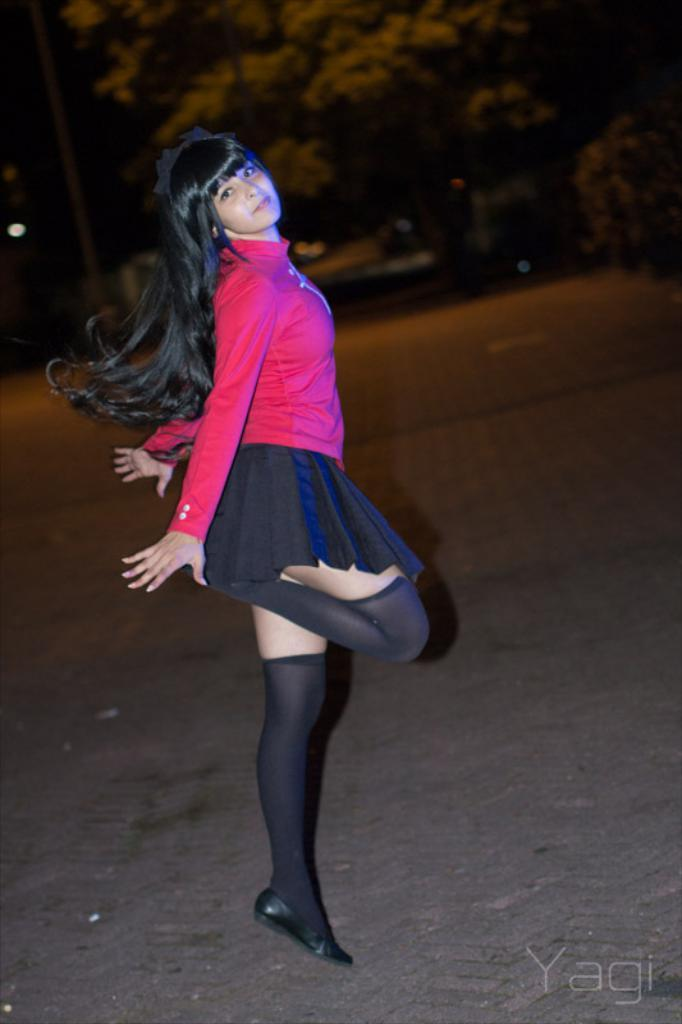Who is the main subject in the image? There is a woman in the image. Can you describe the woman's appearance? The woman has long hair and is wearing a pink shirt. What is the woman's position in the image? The woman is standing on the ground. What can be seen in the background of the image? There is a group of trees in the background of the image. What type of lipstick is the woman wearing in the image? There is no mention of lipstick in the provided facts, so we cannot determine the type of lipstick the woman is wearing. 